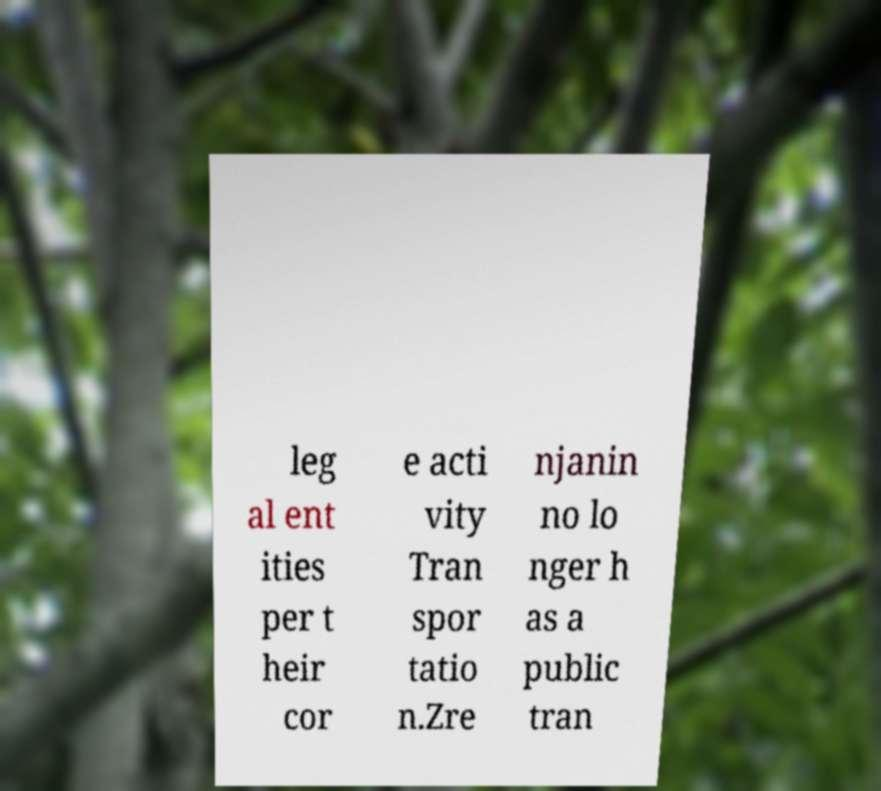Could you extract and type out the text from this image? leg al ent ities per t heir cor e acti vity Tran spor tatio n.Zre njanin no lo nger h as a public tran 